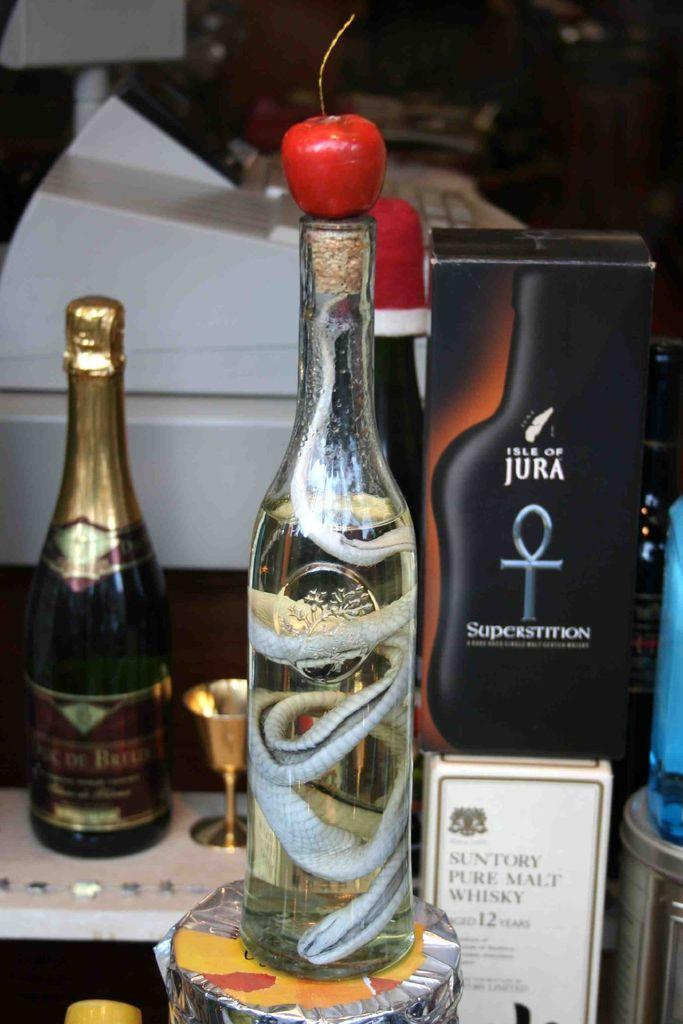Provide a one-sentence caption for the provided image. A box with a picture of a black bottle that says, "Isle of Jura.". 